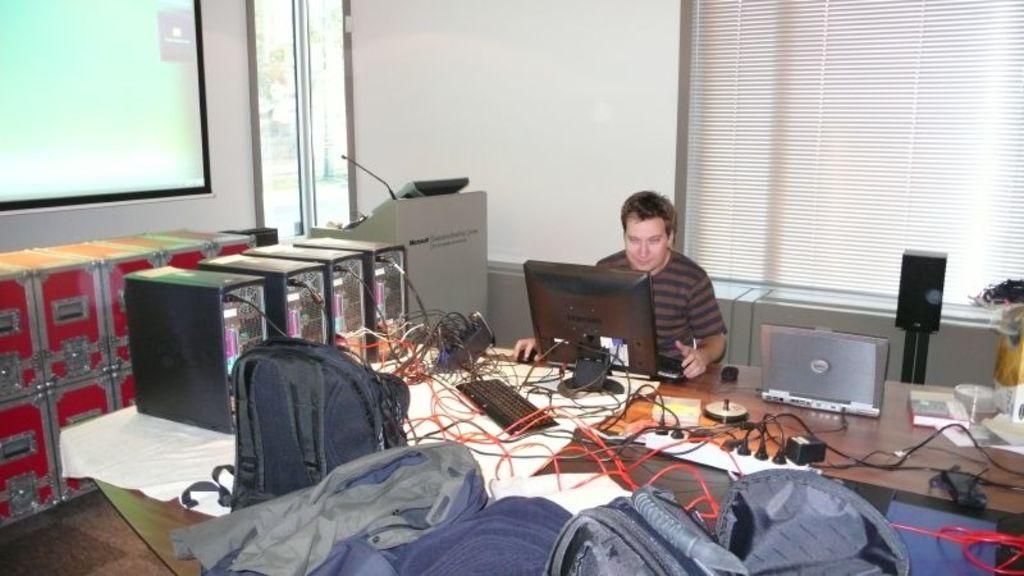Please provide a concise description of this image. In this image i can see a person sitting and doing work in a laptop at right i can see few c. p. u, at the front i can see few bags at the background i can see a window and a wall. 